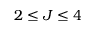Convert formula to latex. <formula><loc_0><loc_0><loc_500><loc_500>2 \leq J \leq 4</formula> 